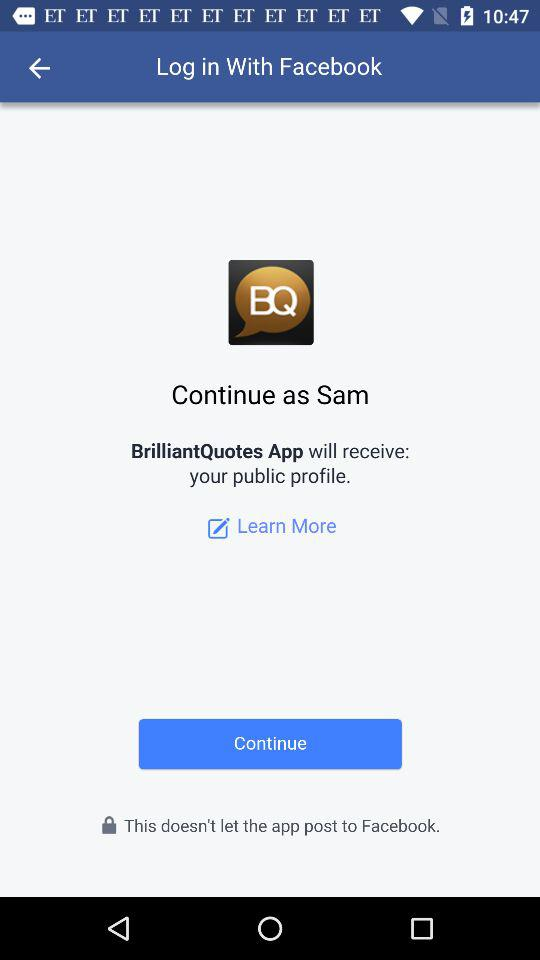What is the name of the user? The name of the user is "Sam". 